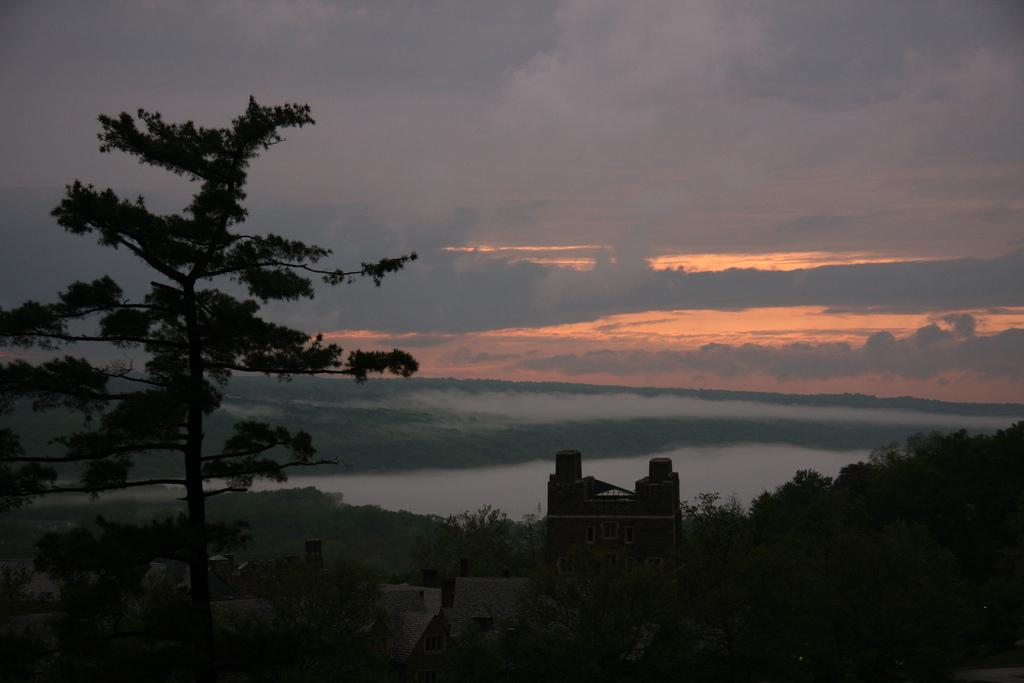What type of structure is visible in the image? There is a house in the image. What can be seen at the bottom side of the image? Greenery is present at the bottom side of the image. What is visible at the top side of the image? The sky is visible at the top side of the image. How many ladybugs can be seen on the house in the image? There are no ladybugs present in the image. What type of scale is used to weigh the house in the image? There is no scale present in the image, and the house is not being weighed. 